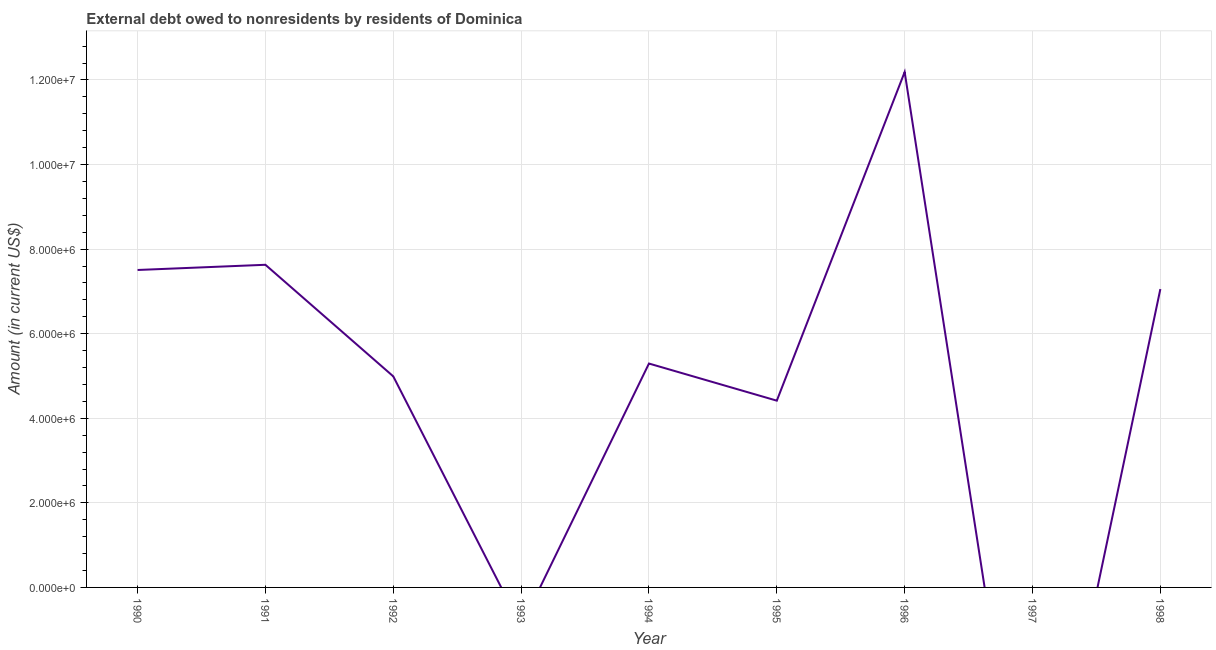What is the debt in 1994?
Your answer should be compact. 5.29e+06. Across all years, what is the maximum debt?
Make the answer very short. 1.22e+07. What is the sum of the debt?
Your answer should be very brief. 4.91e+07. What is the difference between the debt in 1991 and 1992?
Provide a short and direct response. 2.64e+06. What is the average debt per year?
Offer a terse response. 5.45e+06. What is the median debt?
Provide a short and direct response. 5.29e+06. What is the ratio of the debt in 1990 to that in 1998?
Give a very brief answer. 1.06. Is the difference between the debt in 1991 and 1994 greater than the difference between any two years?
Give a very brief answer. No. What is the difference between the highest and the second highest debt?
Ensure brevity in your answer.  4.56e+06. Is the sum of the debt in 1992 and 1996 greater than the maximum debt across all years?
Offer a terse response. Yes. What is the difference between the highest and the lowest debt?
Provide a short and direct response. 1.22e+07. How many lines are there?
Make the answer very short. 1. How many years are there in the graph?
Your answer should be compact. 9. Does the graph contain any zero values?
Your answer should be very brief. Yes. What is the title of the graph?
Provide a short and direct response. External debt owed to nonresidents by residents of Dominica. What is the Amount (in current US$) of 1990?
Provide a succinct answer. 7.51e+06. What is the Amount (in current US$) in 1991?
Your response must be concise. 7.63e+06. What is the Amount (in current US$) in 1992?
Offer a very short reply. 4.99e+06. What is the Amount (in current US$) in 1993?
Your answer should be compact. 0. What is the Amount (in current US$) in 1994?
Your answer should be compact. 5.29e+06. What is the Amount (in current US$) in 1995?
Your answer should be compact. 4.42e+06. What is the Amount (in current US$) in 1996?
Give a very brief answer. 1.22e+07. What is the Amount (in current US$) in 1998?
Keep it short and to the point. 7.06e+06. What is the difference between the Amount (in current US$) in 1990 and 1991?
Provide a short and direct response. -1.23e+05. What is the difference between the Amount (in current US$) in 1990 and 1992?
Keep it short and to the point. 2.52e+06. What is the difference between the Amount (in current US$) in 1990 and 1994?
Offer a very short reply. 2.21e+06. What is the difference between the Amount (in current US$) in 1990 and 1995?
Provide a short and direct response. 3.09e+06. What is the difference between the Amount (in current US$) in 1990 and 1996?
Provide a short and direct response. -4.68e+06. What is the difference between the Amount (in current US$) in 1990 and 1998?
Offer a terse response. 4.51e+05. What is the difference between the Amount (in current US$) in 1991 and 1992?
Offer a terse response. 2.64e+06. What is the difference between the Amount (in current US$) in 1991 and 1994?
Keep it short and to the point. 2.34e+06. What is the difference between the Amount (in current US$) in 1991 and 1995?
Keep it short and to the point. 3.21e+06. What is the difference between the Amount (in current US$) in 1991 and 1996?
Ensure brevity in your answer.  -4.56e+06. What is the difference between the Amount (in current US$) in 1991 and 1998?
Ensure brevity in your answer.  5.74e+05. What is the difference between the Amount (in current US$) in 1992 and 1994?
Provide a succinct answer. -3.03e+05. What is the difference between the Amount (in current US$) in 1992 and 1995?
Make the answer very short. 5.75e+05. What is the difference between the Amount (in current US$) in 1992 and 1996?
Your answer should be compact. -7.20e+06. What is the difference between the Amount (in current US$) in 1992 and 1998?
Provide a succinct answer. -2.06e+06. What is the difference between the Amount (in current US$) in 1994 and 1995?
Provide a succinct answer. 8.78e+05. What is the difference between the Amount (in current US$) in 1994 and 1996?
Keep it short and to the point. -6.89e+06. What is the difference between the Amount (in current US$) in 1994 and 1998?
Ensure brevity in your answer.  -1.76e+06. What is the difference between the Amount (in current US$) in 1995 and 1996?
Give a very brief answer. -7.77e+06. What is the difference between the Amount (in current US$) in 1995 and 1998?
Ensure brevity in your answer.  -2.64e+06. What is the difference between the Amount (in current US$) in 1996 and 1998?
Offer a very short reply. 5.13e+06. What is the ratio of the Amount (in current US$) in 1990 to that in 1991?
Give a very brief answer. 0.98. What is the ratio of the Amount (in current US$) in 1990 to that in 1992?
Offer a very short reply. 1.5. What is the ratio of the Amount (in current US$) in 1990 to that in 1994?
Your answer should be compact. 1.42. What is the ratio of the Amount (in current US$) in 1990 to that in 1995?
Ensure brevity in your answer.  1.7. What is the ratio of the Amount (in current US$) in 1990 to that in 1996?
Provide a short and direct response. 0.62. What is the ratio of the Amount (in current US$) in 1990 to that in 1998?
Keep it short and to the point. 1.06. What is the ratio of the Amount (in current US$) in 1991 to that in 1992?
Ensure brevity in your answer.  1.53. What is the ratio of the Amount (in current US$) in 1991 to that in 1994?
Ensure brevity in your answer.  1.44. What is the ratio of the Amount (in current US$) in 1991 to that in 1995?
Ensure brevity in your answer.  1.73. What is the ratio of the Amount (in current US$) in 1991 to that in 1996?
Give a very brief answer. 0.63. What is the ratio of the Amount (in current US$) in 1991 to that in 1998?
Provide a succinct answer. 1.08. What is the ratio of the Amount (in current US$) in 1992 to that in 1994?
Provide a short and direct response. 0.94. What is the ratio of the Amount (in current US$) in 1992 to that in 1995?
Make the answer very short. 1.13. What is the ratio of the Amount (in current US$) in 1992 to that in 1996?
Your response must be concise. 0.41. What is the ratio of the Amount (in current US$) in 1992 to that in 1998?
Give a very brief answer. 0.71. What is the ratio of the Amount (in current US$) in 1994 to that in 1995?
Keep it short and to the point. 1.2. What is the ratio of the Amount (in current US$) in 1994 to that in 1996?
Offer a very short reply. 0.43. What is the ratio of the Amount (in current US$) in 1995 to that in 1996?
Your response must be concise. 0.36. What is the ratio of the Amount (in current US$) in 1995 to that in 1998?
Provide a short and direct response. 0.63. What is the ratio of the Amount (in current US$) in 1996 to that in 1998?
Your response must be concise. 1.73. 